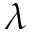Convert formula to latex. <formula><loc_0><loc_0><loc_500><loc_500>\lambda</formula> 